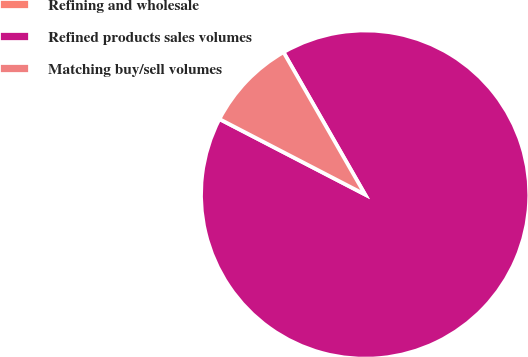Convert chart to OTSL. <chart><loc_0><loc_0><loc_500><loc_500><pie_chart><fcel>Refining and wholesale<fcel>Refined products sales volumes<fcel>Matching buy/sell volumes<nl><fcel>0.01%<fcel>90.9%<fcel>9.1%<nl></chart> 